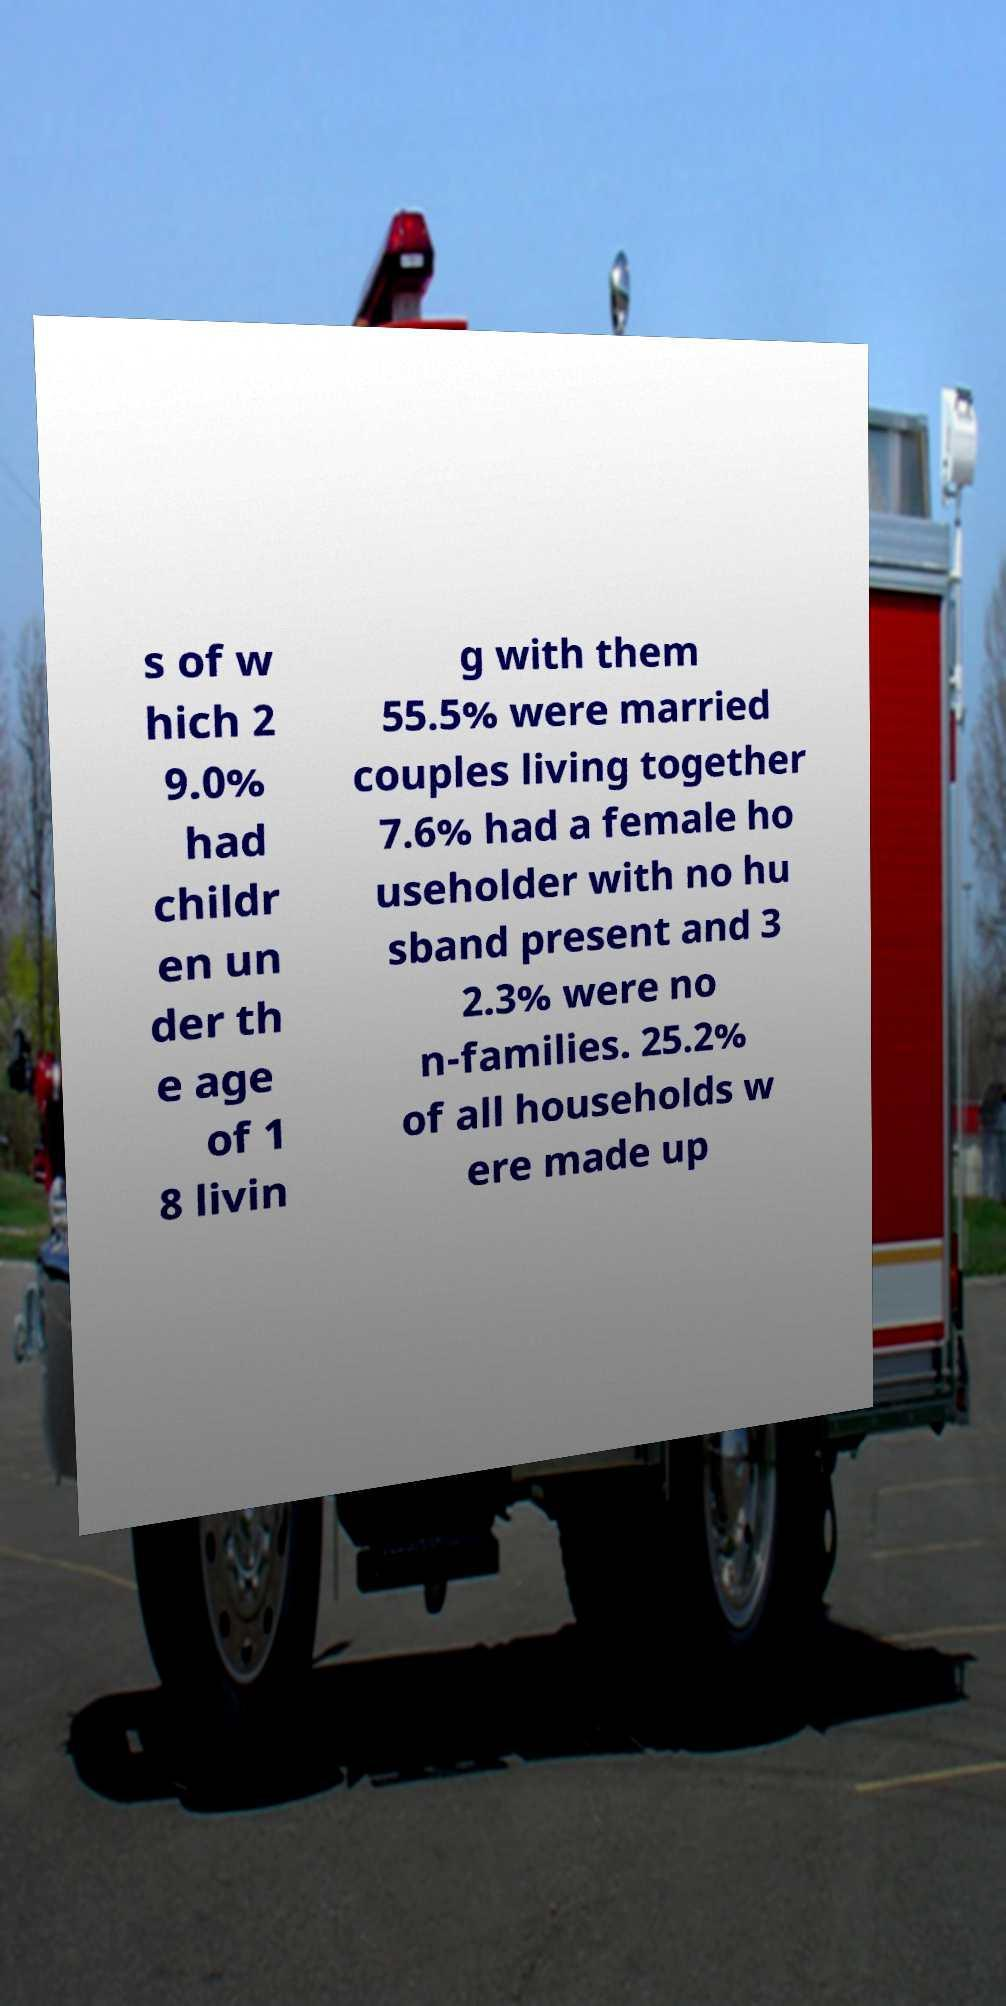Can you read and provide the text displayed in the image?This photo seems to have some interesting text. Can you extract and type it out for me? s of w hich 2 9.0% had childr en un der th e age of 1 8 livin g with them 55.5% were married couples living together 7.6% had a female ho useholder with no hu sband present and 3 2.3% were no n-families. 25.2% of all households w ere made up 